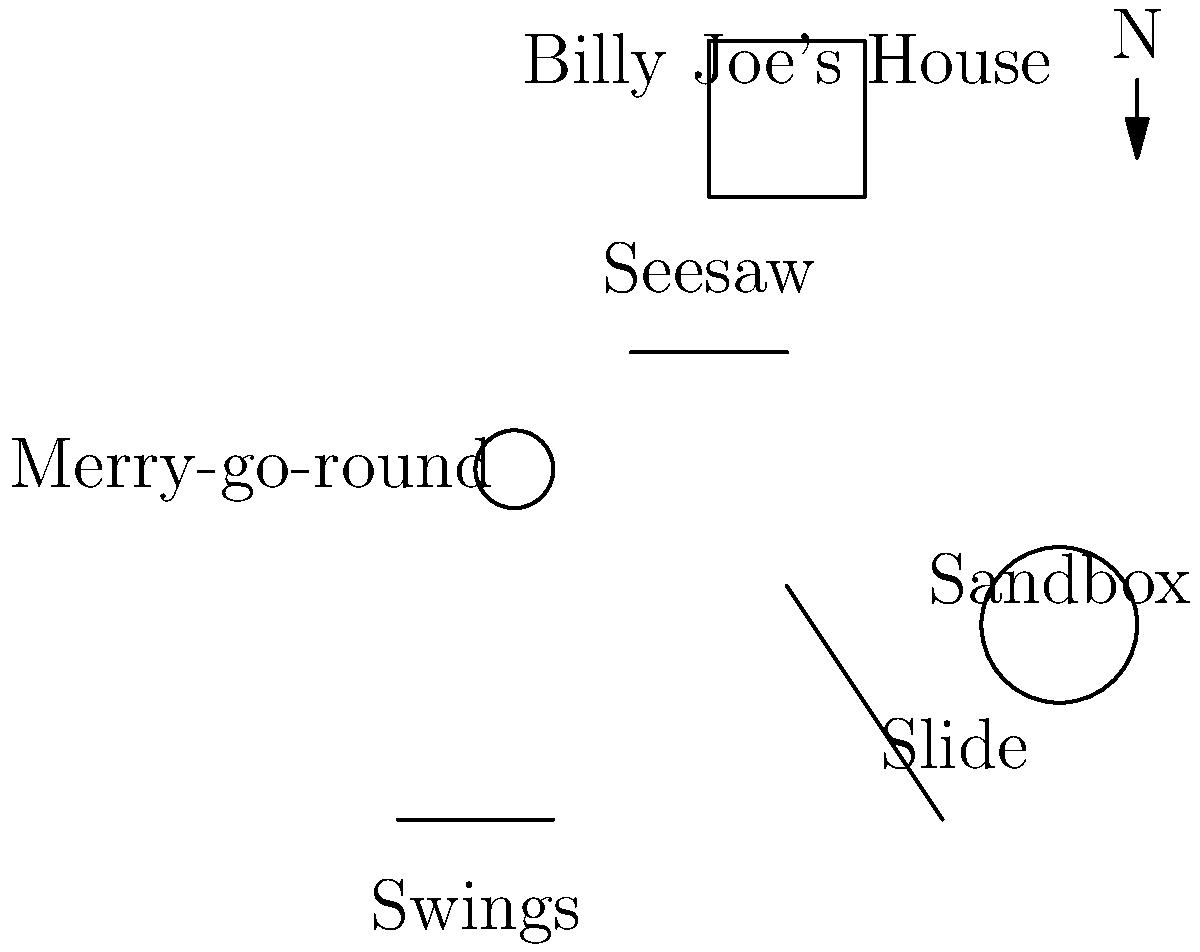In relation to Billy Joe Taylor's house, which playground equipment is located directly south? To answer this question, we need to analyze the map of the neighborhood playground:

1. Locate Billy Joe's house on the map (it's at the top of the image).
2. Identify the direction indicators (the arrow pointing north is in the top-right corner).
3. Look directly south (down) from Billy Joe's house.
4. Observe which playground equipment is in line with the house, moving southward.

Following these steps, we can see that the seesaw is directly below (south of) Billy Joe's house on the map.
Answer: The seesaw 